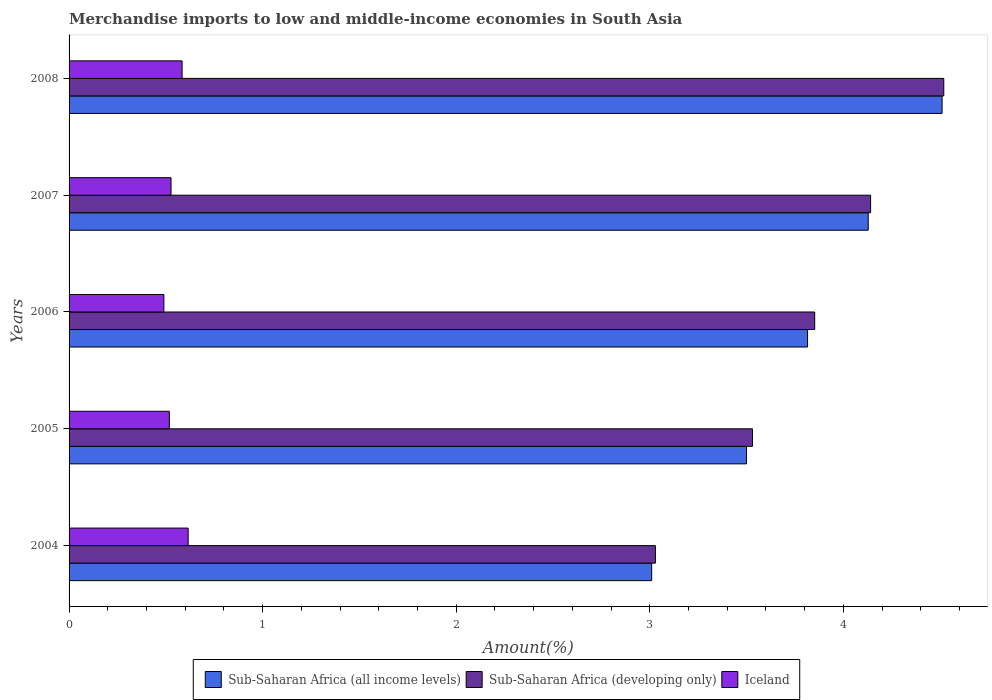Are the number of bars per tick equal to the number of legend labels?
Offer a terse response. Yes. Are the number of bars on each tick of the Y-axis equal?
Provide a succinct answer. Yes. How many bars are there on the 1st tick from the top?
Your answer should be compact. 3. How many bars are there on the 1st tick from the bottom?
Offer a very short reply. 3. What is the label of the 2nd group of bars from the top?
Your answer should be compact. 2007. In how many cases, is the number of bars for a given year not equal to the number of legend labels?
Ensure brevity in your answer.  0. What is the percentage of amount earned from merchandise imports in Sub-Saharan Africa (developing only) in 2007?
Keep it short and to the point. 4.14. Across all years, what is the maximum percentage of amount earned from merchandise imports in Sub-Saharan Africa (all income levels)?
Give a very brief answer. 4.51. Across all years, what is the minimum percentage of amount earned from merchandise imports in Sub-Saharan Africa (all income levels)?
Your answer should be compact. 3.01. In which year was the percentage of amount earned from merchandise imports in Sub-Saharan Africa (developing only) minimum?
Make the answer very short. 2004. What is the total percentage of amount earned from merchandise imports in Sub-Saharan Africa (all income levels) in the graph?
Your answer should be very brief. 18.96. What is the difference between the percentage of amount earned from merchandise imports in Iceland in 2006 and that in 2008?
Provide a short and direct response. -0.09. What is the difference between the percentage of amount earned from merchandise imports in Iceland in 2005 and the percentage of amount earned from merchandise imports in Sub-Saharan Africa (developing only) in 2007?
Your answer should be very brief. -3.62. What is the average percentage of amount earned from merchandise imports in Sub-Saharan Africa (all income levels) per year?
Offer a very short reply. 3.79. In the year 2004, what is the difference between the percentage of amount earned from merchandise imports in Sub-Saharan Africa (developing only) and percentage of amount earned from merchandise imports in Sub-Saharan Africa (all income levels)?
Make the answer very short. 0.02. What is the ratio of the percentage of amount earned from merchandise imports in Sub-Saharan Africa (developing only) in 2004 to that in 2005?
Your answer should be very brief. 0.86. Is the percentage of amount earned from merchandise imports in Iceland in 2007 less than that in 2008?
Make the answer very short. Yes. What is the difference between the highest and the second highest percentage of amount earned from merchandise imports in Sub-Saharan Africa (developing only)?
Offer a terse response. 0.38. What is the difference between the highest and the lowest percentage of amount earned from merchandise imports in Sub-Saharan Africa (developing only)?
Your answer should be very brief. 1.49. Is the sum of the percentage of amount earned from merchandise imports in Sub-Saharan Africa (all income levels) in 2007 and 2008 greater than the maximum percentage of amount earned from merchandise imports in Sub-Saharan Africa (developing only) across all years?
Your response must be concise. Yes. What does the 3rd bar from the top in 2008 represents?
Provide a short and direct response. Sub-Saharan Africa (all income levels). What does the 2nd bar from the bottom in 2008 represents?
Your answer should be compact. Sub-Saharan Africa (developing only). Is it the case that in every year, the sum of the percentage of amount earned from merchandise imports in Sub-Saharan Africa (all income levels) and percentage of amount earned from merchandise imports in Sub-Saharan Africa (developing only) is greater than the percentage of amount earned from merchandise imports in Iceland?
Offer a very short reply. Yes. What is the difference between two consecutive major ticks on the X-axis?
Give a very brief answer. 1. Are the values on the major ticks of X-axis written in scientific E-notation?
Ensure brevity in your answer.  No. Does the graph contain any zero values?
Your answer should be compact. No. Does the graph contain grids?
Offer a terse response. No. How are the legend labels stacked?
Your answer should be compact. Horizontal. What is the title of the graph?
Ensure brevity in your answer.  Merchandise imports to low and middle-income economies in South Asia. Does "Chile" appear as one of the legend labels in the graph?
Ensure brevity in your answer.  No. What is the label or title of the X-axis?
Ensure brevity in your answer.  Amount(%). What is the label or title of the Y-axis?
Provide a short and direct response. Years. What is the Amount(%) of Sub-Saharan Africa (all income levels) in 2004?
Provide a succinct answer. 3.01. What is the Amount(%) in Sub-Saharan Africa (developing only) in 2004?
Make the answer very short. 3.03. What is the Amount(%) of Iceland in 2004?
Keep it short and to the point. 0.62. What is the Amount(%) in Sub-Saharan Africa (all income levels) in 2005?
Make the answer very short. 3.5. What is the Amount(%) in Sub-Saharan Africa (developing only) in 2005?
Offer a terse response. 3.53. What is the Amount(%) in Iceland in 2005?
Your answer should be very brief. 0.52. What is the Amount(%) in Sub-Saharan Africa (all income levels) in 2006?
Your answer should be very brief. 3.82. What is the Amount(%) of Sub-Saharan Africa (developing only) in 2006?
Provide a succinct answer. 3.85. What is the Amount(%) in Iceland in 2006?
Ensure brevity in your answer.  0.49. What is the Amount(%) in Sub-Saharan Africa (all income levels) in 2007?
Ensure brevity in your answer.  4.13. What is the Amount(%) of Sub-Saharan Africa (developing only) in 2007?
Keep it short and to the point. 4.14. What is the Amount(%) in Iceland in 2007?
Offer a very short reply. 0.53. What is the Amount(%) of Sub-Saharan Africa (all income levels) in 2008?
Give a very brief answer. 4.51. What is the Amount(%) in Sub-Saharan Africa (developing only) in 2008?
Your response must be concise. 4.52. What is the Amount(%) in Iceland in 2008?
Your answer should be compact. 0.58. Across all years, what is the maximum Amount(%) in Sub-Saharan Africa (all income levels)?
Keep it short and to the point. 4.51. Across all years, what is the maximum Amount(%) in Sub-Saharan Africa (developing only)?
Your answer should be very brief. 4.52. Across all years, what is the maximum Amount(%) in Iceland?
Offer a terse response. 0.62. Across all years, what is the minimum Amount(%) in Sub-Saharan Africa (all income levels)?
Offer a terse response. 3.01. Across all years, what is the minimum Amount(%) in Sub-Saharan Africa (developing only)?
Keep it short and to the point. 3.03. Across all years, what is the minimum Amount(%) in Iceland?
Keep it short and to the point. 0.49. What is the total Amount(%) in Sub-Saharan Africa (all income levels) in the graph?
Your response must be concise. 18.96. What is the total Amount(%) in Sub-Saharan Africa (developing only) in the graph?
Your answer should be compact. 19.07. What is the total Amount(%) of Iceland in the graph?
Your answer should be very brief. 2.73. What is the difference between the Amount(%) of Sub-Saharan Africa (all income levels) in 2004 and that in 2005?
Your answer should be very brief. -0.49. What is the difference between the Amount(%) in Sub-Saharan Africa (developing only) in 2004 and that in 2005?
Keep it short and to the point. -0.5. What is the difference between the Amount(%) in Iceland in 2004 and that in 2005?
Your answer should be compact. 0.1. What is the difference between the Amount(%) in Sub-Saharan Africa (all income levels) in 2004 and that in 2006?
Offer a terse response. -0.81. What is the difference between the Amount(%) of Sub-Saharan Africa (developing only) in 2004 and that in 2006?
Provide a short and direct response. -0.82. What is the difference between the Amount(%) of Iceland in 2004 and that in 2006?
Make the answer very short. 0.13. What is the difference between the Amount(%) in Sub-Saharan Africa (all income levels) in 2004 and that in 2007?
Offer a very short reply. -1.12. What is the difference between the Amount(%) of Sub-Saharan Africa (developing only) in 2004 and that in 2007?
Provide a succinct answer. -1.11. What is the difference between the Amount(%) of Iceland in 2004 and that in 2007?
Provide a short and direct response. 0.09. What is the difference between the Amount(%) in Sub-Saharan Africa (all income levels) in 2004 and that in 2008?
Your answer should be very brief. -1.5. What is the difference between the Amount(%) in Sub-Saharan Africa (developing only) in 2004 and that in 2008?
Offer a terse response. -1.49. What is the difference between the Amount(%) in Iceland in 2004 and that in 2008?
Offer a very short reply. 0.03. What is the difference between the Amount(%) of Sub-Saharan Africa (all income levels) in 2005 and that in 2006?
Provide a short and direct response. -0.32. What is the difference between the Amount(%) of Sub-Saharan Africa (developing only) in 2005 and that in 2006?
Provide a short and direct response. -0.32. What is the difference between the Amount(%) of Iceland in 2005 and that in 2006?
Give a very brief answer. 0.03. What is the difference between the Amount(%) of Sub-Saharan Africa (all income levels) in 2005 and that in 2007?
Your answer should be very brief. -0.63. What is the difference between the Amount(%) in Sub-Saharan Africa (developing only) in 2005 and that in 2007?
Provide a short and direct response. -0.61. What is the difference between the Amount(%) in Iceland in 2005 and that in 2007?
Make the answer very short. -0.01. What is the difference between the Amount(%) in Sub-Saharan Africa (all income levels) in 2005 and that in 2008?
Ensure brevity in your answer.  -1.01. What is the difference between the Amount(%) in Sub-Saharan Africa (developing only) in 2005 and that in 2008?
Your answer should be very brief. -0.99. What is the difference between the Amount(%) of Iceland in 2005 and that in 2008?
Your response must be concise. -0.07. What is the difference between the Amount(%) in Sub-Saharan Africa (all income levels) in 2006 and that in 2007?
Your answer should be very brief. -0.31. What is the difference between the Amount(%) of Sub-Saharan Africa (developing only) in 2006 and that in 2007?
Your answer should be very brief. -0.29. What is the difference between the Amount(%) of Iceland in 2006 and that in 2007?
Your response must be concise. -0.04. What is the difference between the Amount(%) of Sub-Saharan Africa (all income levels) in 2006 and that in 2008?
Offer a terse response. -0.69. What is the difference between the Amount(%) in Sub-Saharan Africa (developing only) in 2006 and that in 2008?
Offer a terse response. -0.67. What is the difference between the Amount(%) of Iceland in 2006 and that in 2008?
Offer a very short reply. -0.09. What is the difference between the Amount(%) in Sub-Saharan Africa (all income levels) in 2007 and that in 2008?
Your answer should be very brief. -0.38. What is the difference between the Amount(%) in Sub-Saharan Africa (developing only) in 2007 and that in 2008?
Provide a succinct answer. -0.38. What is the difference between the Amount(%) of Iceland in 2007 and that in 2008?
Make the answer very short. -0.06. What is the difference between the Amount(%) of Sub-Saharan Africa (all income levels) in 2004 and the Amount(%) of Sub-Saharan Africa (developing only) in 2005?
Your response must be concise. -0.52. What is the difference between the Amount(%) in Sub-Saharan Africa (all income levels) in 2004 and the Amount(%) in Iceland in 2005?
Your answer should be very brief. 2.49. What is the difference between the Amount(%) in Sub-Saharan Africa (developing only) in 2004 and the Amount(%) in Iceland in 2005?
Provide a short and direct response. 2.51. What is the difference between the Amount(%) of Sub-Saharan Africa (all income levels) in 2004 and the Amount(%) of Sub-Saharan Africa (developing only) in 2006?
Make the answer very short. -0.84. What is the difference between the Amount(%) of Sub-Saharan Africa (all income levels) in 2004 and the Amount(%) of Iceland in 2006?
Give a very brief answer. 2.52. What is the difference between the Amount(%) of Sub-Saharan Africa (developing only) in 2004 and the Amount(%) of Iceland in 2006?
Provide a succinct answer. 2.54. What is the difference between the Amount(%) of Sub-Saharan Africa (all income levels) in 2004 and the Amount(%) of Sub-Saharan Africa (developing only) in 2007?
Your response must be concise. -1.13. What is the difference between the Amount(%) of Sub-Saharan Africa (all income levels) in 2004 and the Amount(%) of Iceland in 2007?
Provide a succinct answer. 2.48. What is the difference between the Amount(%) of Sub-Saharan Africa (developing only) in 2004 and the Amount(%) of Iceland in 2007?
Make the answer very short. 2.5. What is the difference between the Amount(%) in Sub-Saharan Africa (all income levels) in 2004 and the Amount(%) in Sub-Saharan Africa (developing only) in 2008?
Your response must be concise. -1.51. What is the difference between the Amount(%) of Sub-Saharan Africa (all income levels) in 2004 and the Amount(%) of Iceland in 2008?
Ensure brevity in your answer.  2.43. What is the difference between the Amount(%) in Sub-Saharan Africa (developing only) in 2004 and the Amount(%) in Iceland in 2008?
Give a very brief answer. 2.45. What is the difference between the Amount(%) of Sub-Saharan Africa (all income levels) in 2005 and the Amount(%) of Sub-Saharan Africa (developing only) in 2006?
Offer a very short reply. -0.35. What is the difference between the Amount(%) in Sub-Saharan Africa (all income levels) in 2005 and the Amount(%) in Iceland in 2006?
Keep it short and to the point. 3.01. What is the difference between the Amount(%) of Sub-Saharan Africa (developing only) in 2005 and the Amount(%) of Iceland in 2006?
Your response must be concise. 3.04. What is the difference between the Amount(%) in Sub-Saharan Africa (all income levels) in 2005 and the Amount(%) in Sub-Saharan Africa (developing only) in 2007?
Give a very brief answer. -0.64. What is the difference between the Amount(%) in Sub-Saharan Africa (all income levels) in 2005 and the Amount(%) in Iceland in 2007?
Keep it short and to the point. 2.97. What is the difference between the Amount(%) in Sub-Saharan Africa (developing only) in 2005 and the Amount(%) in Iceland in 2007?
Ensure brevity in your answer.  3. What is the difference between the Amount(%) of Sub-Saharan Africa (all income levels) in 2005 and the Amount(%) of Sub-Saharan Africa (developing only) in 2008?
Your response must be concise. -1.02. What is the difference between the Amount(%) in Sub-Saharan Africa (all income levels) in 2005 and the Amount(%) in Iceland in 2008?
Your response must be concise. 2.92. What is the difference between the Amount(%) of Sub-Saharan Africa (developing only) in 2005 and the Amount(%) of Iceland in 2008?
Offer a terse response. 2.95. What is the difference between the Amount(%) of Sub-Saharan Africa (all income levels) in 2006 and the Amount(%) of Sub-Saharan Africa (developing only) in 2007?
Provide a succinct answer. -0.33. What is the difference between the Amount(%) of Sub-Saharan Africa (all income levels) in 2006 and the Amount(%) of Iceland in 2007?
Ensure brevity in your answer.  3.29. What is the difference between the Amount(%) in Sub-Saharan Africa (developing only) in 2006 and the Amount(%) in Iceland in 2007?
Provide a short and direct response. 3.33. What is the difference between the Amount(%) in Sub-Saharan Africa (all income levels) in 2006 and the Amount(%) in Sub-Saharan Africa (developing only) in 2008?
Give a very brief answer. -0.7. What is the difference between the Amount(%) in Sub-Saharan Africa (all income levels) in 2006 and the Amount(%) in Iceland in 2008?
Make the answer very short. 3.23. What is the difference between the Amount(%) in Sub-Saharan Africa (developing only) in 2006 and the Amount(%) in Iceland in 2008?
Offer a terse response. 3.27. What is the difference between the Amount(%) in Sub-Saharan Africa (all income levels) in 2007 and the Amount(%) in Sub-Saharan Africa (developing only) in 2008?
Provide a succinct answer. -0.39. What is the difference between the Amount(%) in Sub-Saharan Africa (all income levels) in 2007 and the Amount(%) in Iceland in 2008?
Ensure brevity in your answer.  3.54. What is the difference between the Amount(%) in Sub-Saharan Africa (developing only) in 2007 and the Amount(%) in Iceland in 2008?
Ensure brevity in your answer.  3.56. What is the average Amount(%) of Sub-Saharan Africa (all income levels) per year?
Your answer should be very brief. 3.79. What is the average Amount(%) of Sub-Saharan Africa (developing only) per year?
Your answer should be compact. 3.81. What is the average Amount(%) in Iceland per year?
Your answer should be very brief. 0.55. In the year 2004, what is the difference between the Amount(%) of Sub-Saharan Africa (all income levels) and Amount(%) of Sub-Saharan Africa (developing only)?
Your answer should be very brief. -0.02. In the year 2004, what is the difference between the Amount(%) in Sub-Saharan Africa (all income levels) and Amount(%) in Iceland?
Offer a terse response. 2.39. In the year 2004, what is the difference between the Amount(%) in Sub-Saharan Africa (developing only) and Amount(%) in Iceland?
Your answer should be very brief. 2.41. In the year 2005, what is the difference between the Amount(%) in Sub-Saharan Africa (all income levels) and Amount(%) in Sub-Saharan Africa (developing only)?
Offer a terse response. -0.03. In the year 2005, what is the difference between the Amount(%) in Sub-Saharan Africa (all income levels) and Amount(%) in Iceland?
Provide a short and direct response. 2.98. In the year 2005, what is the difference between the Amount(%) of Sub-Saharan Africa (developing only) and Amount(%) of Iceland?
Keep it short and to the point. 3.01. In the year 2006, what is the difference between the Amount(%) in Sub-Saharan Africa (all income levels) and Amount(%) in Sub-Saharan Africa (developing only)?
Make the answer very short. -0.04. In the year 2006, what is the difference between the Amount(%) of Sub-Saharan Africa (all income levels) and Amount(%) of Iceland?
Your answer should be very brief. 3.33. In the year 2006, what is the difference between the Amount(%) of Sub-Saharan Africa (developing only) and Amount(%) of Iceland?
Provide a succinct answer. 3.36. In the year 2007, what is the difference between the Amount(%) of Sub-Saharan Africa (all income levels) and Amount(%) of Sub-Saharan Africa (developing only)?
Your answer should be compact. -0.01. In the year 2007, what is the difference between the Amount(%) of Sub-Saharan Africa (all income levels) and Amount(%) of Iceland?
Provide a short and direct response. 3.6. In the year 2007, what is the difference between the Amount(%) of Sub-Saharan Africa (developing only) and Amount(%) of Iceland?
Your answer should be very brief. 3.61. In the year 2008, what is the difference between the Amount(%) of Sub-Saharan Africa (all income levels) and Amount(%) of Sub-Saharan Africa (developing only)?
Give a very brief answer. -0.01. In the year 2008, what is the difference between the Amount(%) in Sub-Saharan Africa (all income levels) and Amount(%) in Iceland?
Your answer should be compact. 3.93. In the year 2008, what is the difference between the Amount(%) of Sub-Saharan Africa (developing only) and Amount(%) of Iceland?
Ensure brevity in your answer.  3.93. What is the ratio of the Amount(%) of Sub-Saharan Africa (all income levels) in 2004 to that in 2005?
Ensure brevity in your answer.  0.86. What is the ratio of the Amount(%) of Sub-Saharan Africa (developing only) in 2004 to that in 2005?
Ensure brevity in your answer.  0.86. What is the ratio of the Amount(%) in Iceland in 2004 to that in 2005?
Provide a succinct answer. 1.19. What is the ratio of the Amount(%) of Sub-Saharan Africa (all income levels) in 2004 to that in 2006?
Provide a succinct answer. 0.79. What is the ratio of the Amount(%) of Sub-Saharan Africa (developing only) in 2004 to that in 2006?
Your response must be concise. 0.79. What is the ratio of the Amount(%) of Iceland in 2004 to that in 2006?
Provide a succinct answer. 1.26. What is the ratio of the Amount(%) in Sub-Saharan Africa (all income levels) in 2004 to that in 2007?
Give a very brief answer. 0.73. What is the ratio of the Amount(%) of Sub-Saharan Africa (developing only) in 2004 to that in 2007?
Your answer should be very brief. 0.73. What is the ratio of the Amount(%) of Iceland in 2004 to that in 2007?
Your answer should be very brief. 1.17. What is the ratio of the Amount(%) of Sub-Saharan Africa (all income levels) in 2004 to that in 2008?
Provide a succinct answer. 0.67. What is the ratio of the Amount(%) in Sub-Saharan Africa (developing only) in 2004 to that in 2008?
Offer a very short reply. 0.67. What is the ratio of the Amount(%) of Iceland in 2004 to that in 2008?
Provide a short and direct response. 1.05. What is the ratio of the Amount(%) of Sub-Saharan Africa (all income levels) in 2005 to that in 2006?
Make the answer very short. 0.92. What is the ratio of the Amount(%) of Sub-Saharan Africa (developing only) in 2005 to that in 2006?
Provide a short and direct response. 0.92. What is the ratio of the Amount(%) in Iceland in 2005 to that in 2006?
Keep it short and to the point. 1.06. What is the ratio of the Amount(%) of Sub-Saharan Africa (all income levels) in 2005 to that in 2007?
Offer a very short reply. 0.85. What is the ratio of the Amount(%) in Sub-Saharan Africa (developing only) in 2005 to that in 2007?
Provide a succinct answer. 0.85. What is the ratio of the Amount(%) of Iceland in 2005 to that in 2007?
Provide a short and direct response. 0.98. What is the ratio of the Amount(%) of Sub-Saharan Africa (all income levels) in 2005 to that in 2008?
Your answer should be very brief. 0.78. What is the ratio of the Amount(%) in Sub-Saharan Africa (developing only) in 2005 to that in 2008?
Offer a terse response. 0.78. What is the ratio of the Amount(%) in Iceland in 2005 to that in 2008?
Give a very brief answer. 0.89. What is the ratio of the Amount(%) in Sub-Saharan Africa (all income levels) in 2006 to that in 2007?
Offer a very short reply. 0.92. What is the ratio of the Amount(%) in Sub-Saharan Africa (developing only) in 2006 to that in 2007?
Keep it short and to the point. 0.93. What is the ratio of the Amount(%) in Iceland in 2006 to that in 2007?
Offer a very short reply. 0.93. What is the ratio of the Amount(%) in Sub-Saharan Africa (all income levels) in 2006 to that in 2008?
Your answer should be compact. 0.85. What is the ratio of the Amount(%) in Sub-Saharan Africa (developing only) in 2006 to that in 2008?
Your answer should be very brief. 0.85. What is the ratio of the Amount(%) of Iceland in 2006 to that in 2008?
Your answer should be very brief. 0.84. What is the ratio of the Amount(%) in Sub-Saharan Africa (all income levels) in 2007 to that in 2008?
Provide a short and direct response. 0.92. What is the ratio of the Amount(%) of Sub-Saharan Africa (developing only) in 2007 to that in 2008?
Your response must be concise. 0.92. What is the ratio of the Amount(%) in Iceland in 2007 to that in 2008?
Your response must be concise. 0.9. What is the difference between the highest and the second highest Amount(%) of Sub-Saharan Africa (all income levels)?
Ensure brevity in your answer.  0.38. What is the difference between the highest and the second highest Amount(%) of Sub-Saharan Africa (developing only)?
Provide a short and direct response. 0.38. What is the difference between the highest and the second highest Amount(%) of Iceland?
Make the answer very short. 0.03. What is the difference between the highest and the lowest Amount(%) of Sub-Saharan Africa (all income levels)?
Provide a succinct answer. 1.5. What is the difference between the highest and the lowest Amount(%) of Sub-Saharan Africa (developing only)?
Offer a terse response. 1.49. What is the difference between the highest and the lowest Amount(%) in Iceland?
Ensure brevity in your answer.  0.13. 